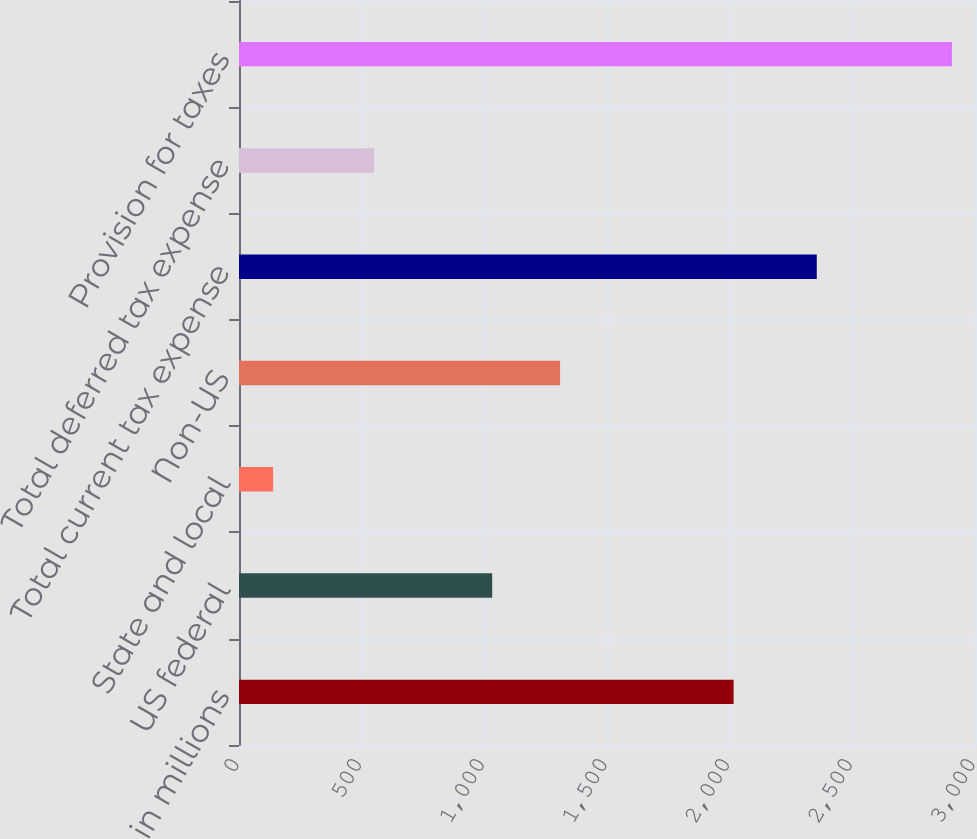<chart> <loc_0><loc_0><loc_500><loc_500><bar_chart><fcel>in millions<fcel>US federal<fcel>State and local<fcel>Non-US<fcel>Total current tax expense<fcel>Total deferred tax expense<fcel>Provision for taxes<nl><fcel>2016<fcel>1032<fcel>139<fcel>1308.7<fcel>2355<fcel>551<fcel>2906<nl></chart> 